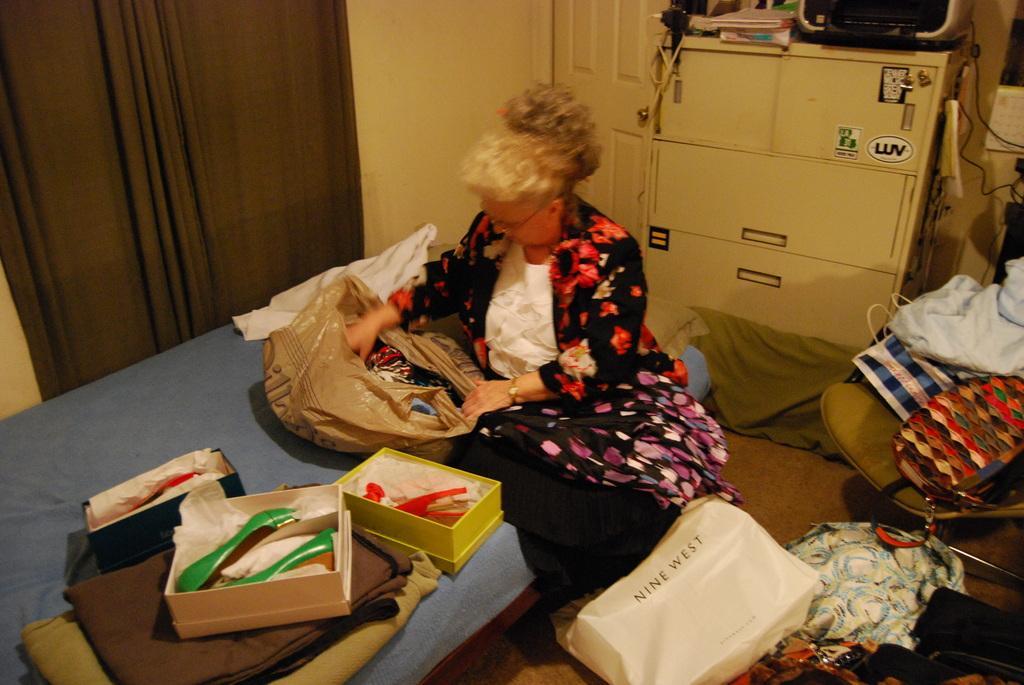Please provide a concise description of this image. In the center of the image we can see one woman sitting on the bed and she is holding one plastic cover. On the bed, we can see boxes, blankets and one plastic cover. In the boxes, we can see different color saddles. In the plastic cover, we can see the clothes. On the right side of the image, we can see one chair, one bag, paper bags, clothes etc. In the background there is a wall, door, curtain, calendar, cupboards, wires, books, one machine and a few other objects. 